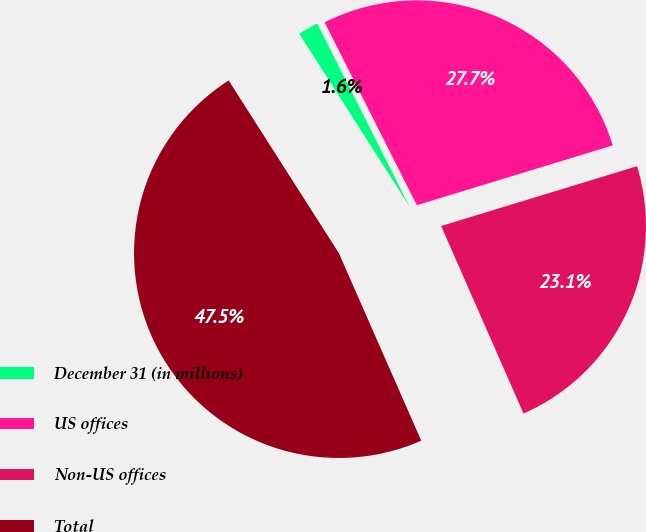<chart> <loc_0><loc_0><loc_500><loc_500><pie_chart><fcel>December 31 (in millions)<fcel>US offices<fcel>Non-US offices<fcel>Total<nl><fcel>1.61%<fcel>27.72%<fcel>23.13%<fcel>47.55%<nl></chart> 